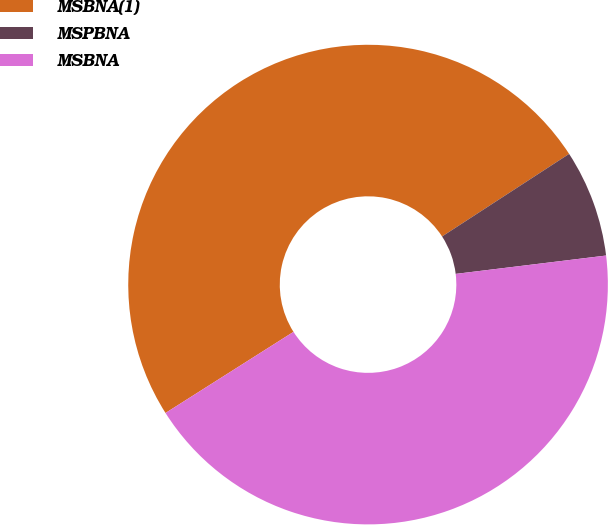Convert chart. <chart><loc_0><loc_0><loc_500><loc_500><pie_chart><fcel>MSBNA(1)<fcel>MSPBNA<fcel>MSBNA<nl><fcel>49.82%<fcel>7.24%<fcel>42.94%<nl></chart> 